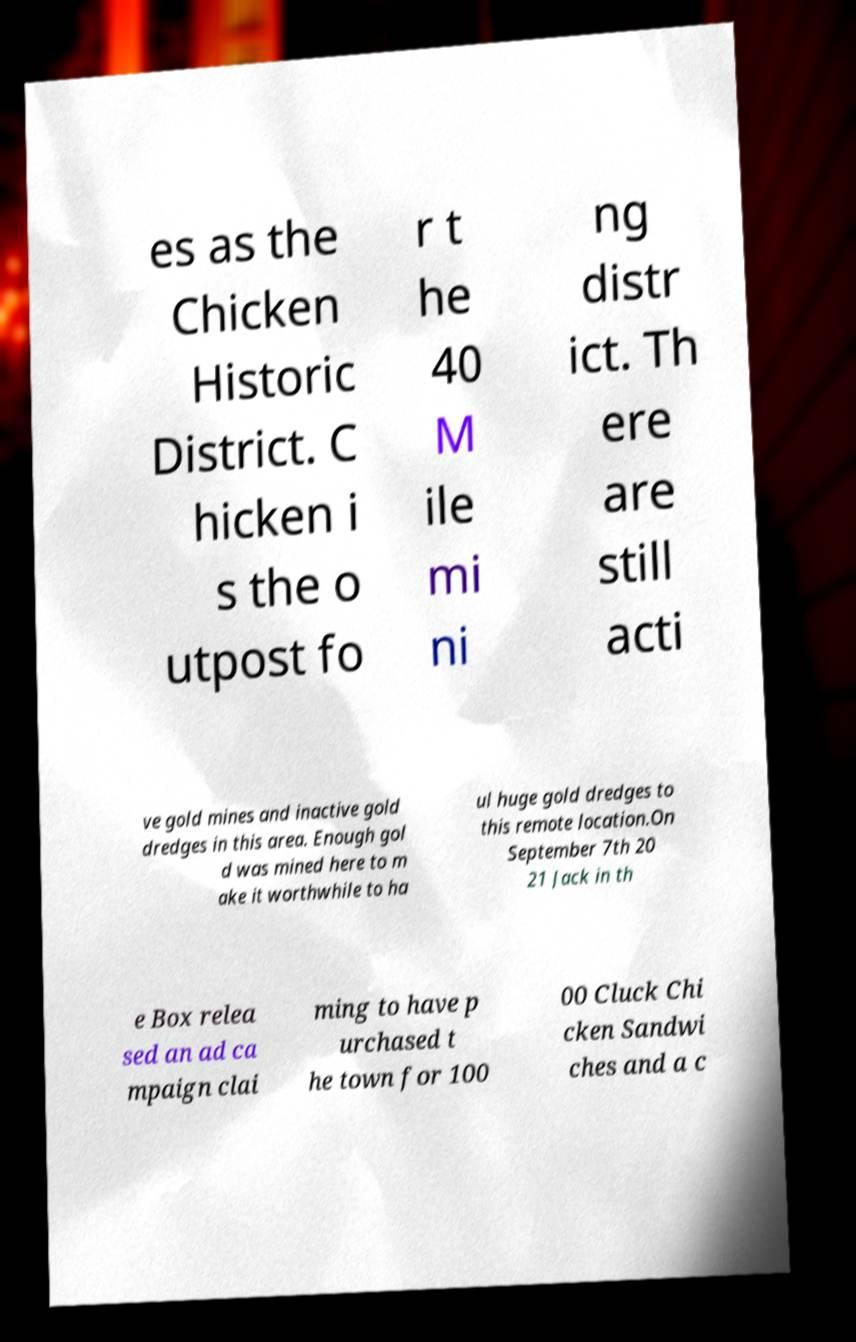Please read and relay the text visible in this image. What does it say? es as the Chicken Historic District. C hicken i s the o utpost fo r t he 40 M ile mi ni ng distr ict. Th ere are still acti ve gold mines and inactive gold dredges in this area. Enough gol d was mined here to m ake it worthwhile to ha ul huge gold dredges to this remote location.On September 7th 20 21 Jack in th e Box relea sed an ad ca mpaign clai ming to have p urchased t he town for 100 00 Cluck Chi cken Sandwi ches and a c 